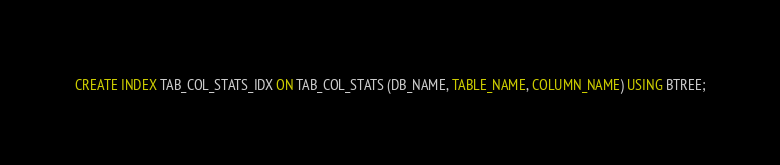<code> <loc_0><loc_0><loc_500><loc_500><_SQL_>CREATE INDEX TAB_COL_STATS_IDX ON TAB_COL_STATS (DB_NAME, TABLE_NAME, COLUMN_NAME) USING BTREE;
</code> 